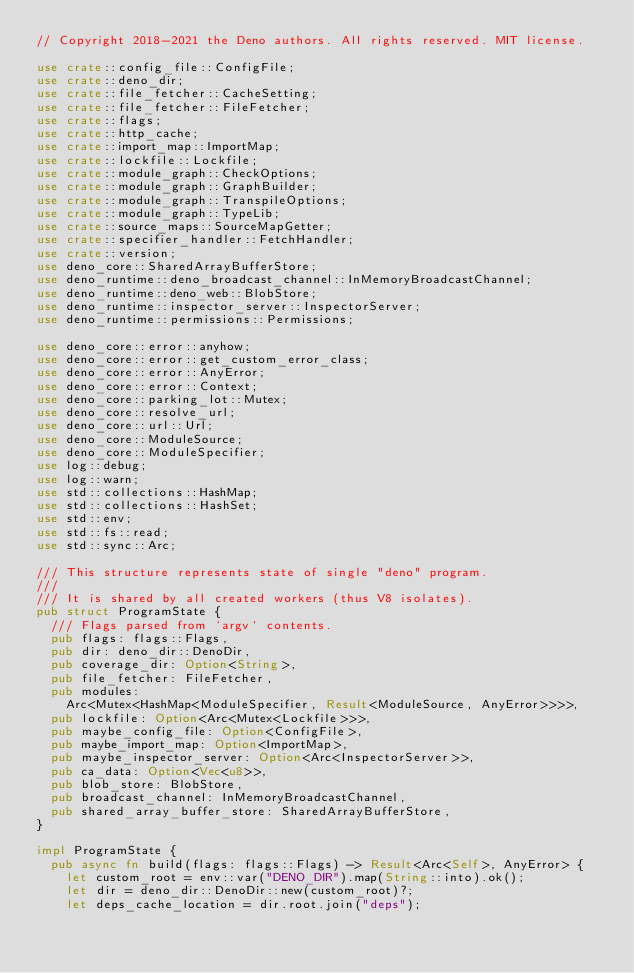<code> <loc_0><loc_0><loc_500><loc_500><_Rust_>// Copyright 2018-2021 the Deno authors. All rights reserved. MIT license.

use crate::config_file::ConfigFile;
use crate::deno_dir;
use crate::file_fetcher::CacheSetting;
use crate::file_fetcher::FileFetcher;
use crate::flags;
use crate::http_cache;
use crate::import_map::ImportMap;
use crate::lockfile::Lockfile;
use crate::module_graph::CheckOptions;
use crate::module_graph::GraphBuilder;
use crate::module_graph::TranspileOptions;
use crate::module_graph::TypeLib;
use crate::source_maps::SourceMapGetter;
use crate::specifier_handler::FetchHandler;
use crate::version;
use deno_core::SharedArrayBufferStore;
use deno_runtime::deno_broadcast_channel::InMemoryBroadcastChannel;
use deno_runtime::deno_web::BlobStore;
use deno_runtime::inspector_server::InspectorServer;
use deno_runtime::permissions::Permissions;

use deno_core::error::anyhow;
use deno_core::error::get_custom_error_class;
use deno_core::error::AnyError;
use deno_core::error::Context;
use deno_core::parking_lot::Mutex;
use deno_core::resolve_url;
use deno_core::url::Url;
use deno_core::ModuleSource;
use deno_core::ModuleSpecifier;
use log::debug;
use log::warn;
use std::collections::HashMap;
use std::collections::HashSet;
use std::env;
use std::fs::read;
use std::sync::Arc;

/// This structure represents state of single "deno" program.
///
/// It is shared by all created workers (thus V8 isolates).
pub struct ProgramState {
  /// Flags parsed from `argv` contents.
  pub flags: flags::Flags,
  pub dir: deno_dir::DenoDir,
  pub coverage_dir: Option<String>,
  pub file_fetcher: FileFetcher,
  pub modules:
    Arc<Mutex<HashMap<ModuleSpecifier, Result<ModuleSource, AnyError>>>>,
  pub lockfile: Option<Arc<Mutex<Lockfile>>>,
  pub maybe_config_file: Option<ConfigFile>,
  pub maybe_import_map: Option<ImportMap>,
  pub maybe_inspector_server: Option<Arc<InspectorServer>>,
  pub ca_data: Option<Vec<u8>>,
  pub blob_store: BlobStore,
  pub broadcast_channel: InMemoryBroadcastChannel,
  pub shared_array_buffer_store: SharedArrayBufferStore,
}

impl ProgramState {
  pub async fn build(flags: flags::Flags) -> Result<Arc<Self>, AnyError> {
    let custom_root = env::var("DENO_DIR").map(String::into).ok();
    let dir = deno_dir::DenoDir::new(custom_root)?;
    let deps_cache_location = dir.root.join("deps");</code> 